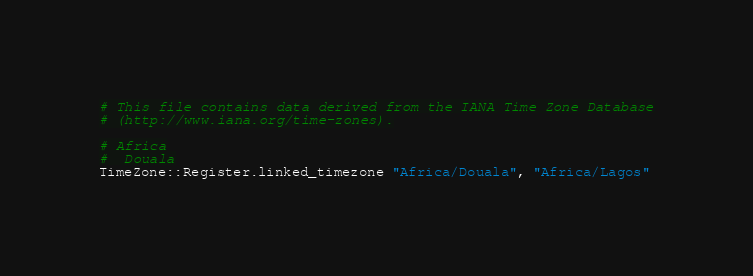Convert code to text. <code><loc_0><loc_0><loc_500><loc_500><_Crystal_># This file contains data derived from the IANA Time Zone Database
# (http://www.iana.org/time-zones).

# Africa
#  Douala
TimeZone::Register.linked_timezone "Africa/Douala", "Africa/Lagos"
</code> 